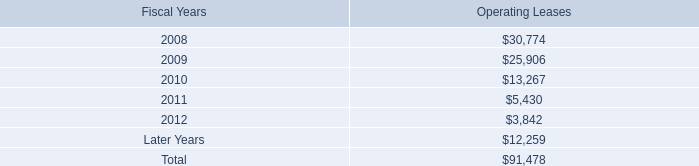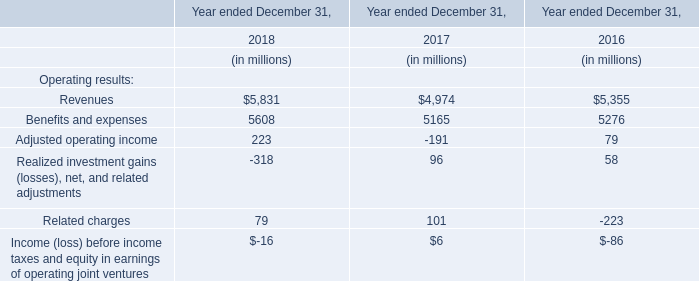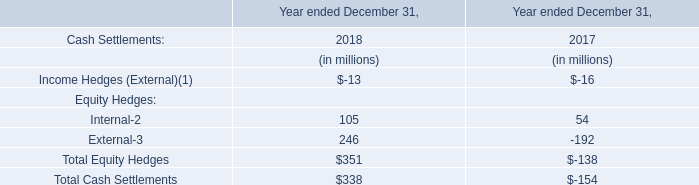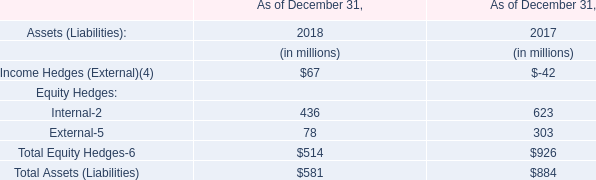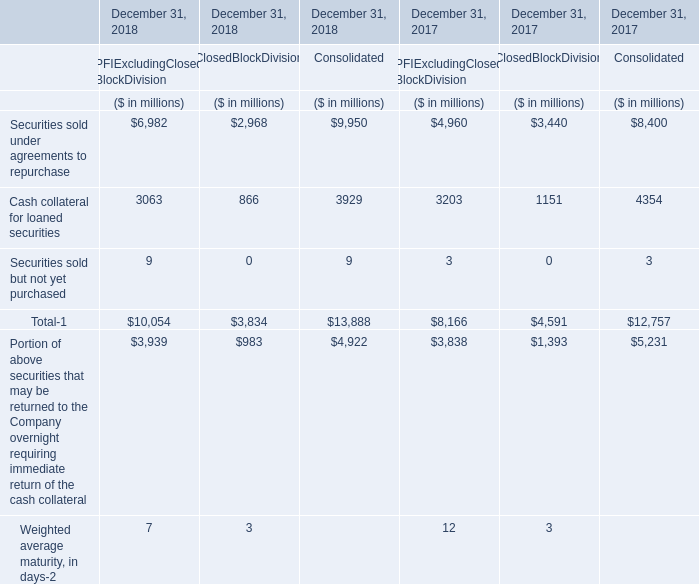What was the average value of Cash collateral for loaned securities, Securities sold but not yet purchased , Total-1 in 2018 for Consolidated? (in million) 
Computations: (((3929 + 9) + 13888) / 3)
Answer: 5942.0. 